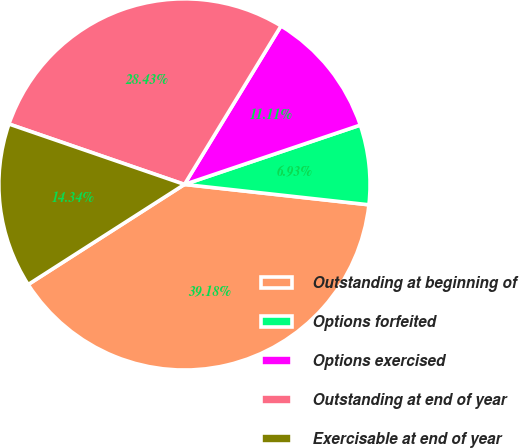Convert chart to OTSL. <chart><loc_0><loc_0><loc_500><loc_500><pie_chart><fcel>Outstanding at beginning of<fcel>Options forfeited<fcel>Options exercised<fcel>Outstanding at end of year<fcel>Exercisable at end of year<nl><fcel>39.18%<fcel>6.93%<fcel>11.11%<fcel>28.43%<fcel>14.34%<nl></chart> 